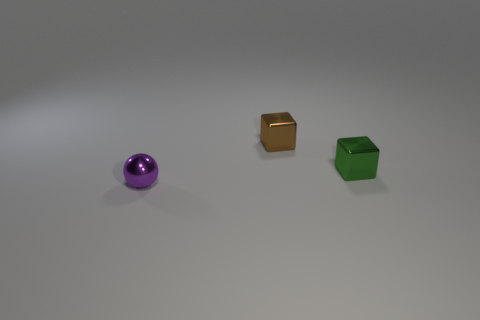Add 2 small green shiny blocks. How many objects exist? 5 Subtract all green blocks. How many blocks are left? 1 Subtract all spheres. How many objects are left? 2 Subtract all green matte cylinders. Subtract all tiny green metal things. How many objects are left? 2 Add 3 green shiny objects. How many green shiny objects are left? 4 Add 2 shiny things. How many shiny things exist? 5 Subtract 0 cyan balls. How many objects are left? 3 Subtract all green balls. Subtract all brown cubes. How many balls are left? 1 